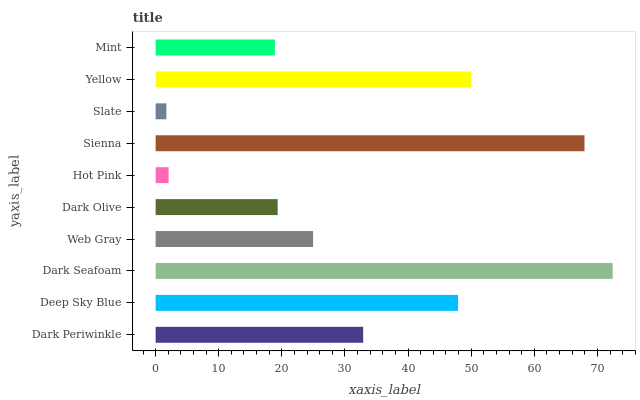Is Slate the minimum?
Answer yes or no. Yes. Is Dark Seafoam the maximum?
Answer yes or no. Yes. Is Deep Sky Blue the minimum?
Answer yes or no. No. Is Deep Sky Blue the maximum?
Answer yes or no. No. Is Deep Sky Blue greater than Dark Periwinkle?
Answer yes or no. Yes. Is Dark Periwinkle less than Deep Sky Blue?
Answer yes or no. Yes. Is Dark Periwinkle greater than Deep Sky Blue?
Answer yes or no. No. Is Deep Sky Blue less than Dark Periwinkle?
Answer yes or no. No. Is Dark Periwinkle the high median?
Answer yes or no. Yes. Is Web Gray the low median?
Answer yes or no. Yes. Is Sienna the high median?
Answer yes or no. No. Is Dark Olive the low median?
Answer yes or no. No. 